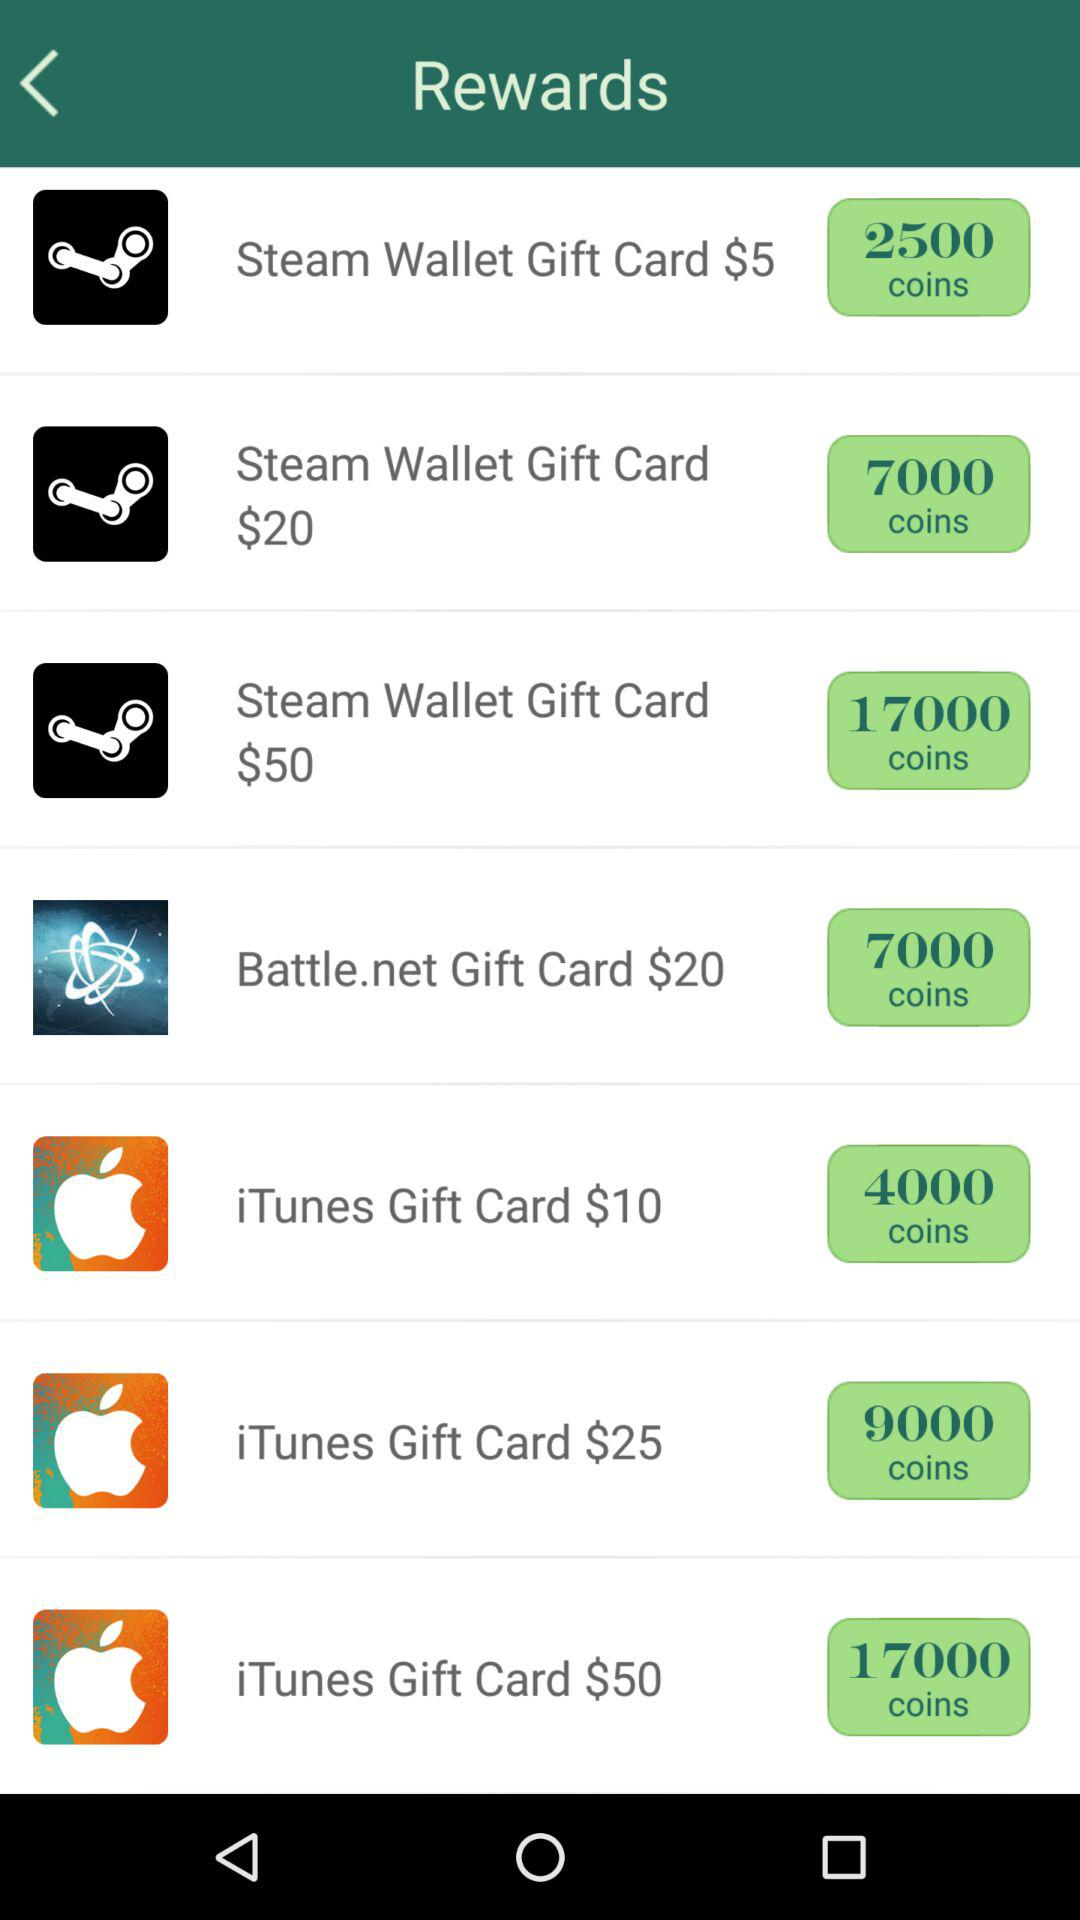How many more coins does the $25 iTunes Gift Card offer than the $10 iTunes Gift Card?
Answer the question using a single word or phrase. 5000 